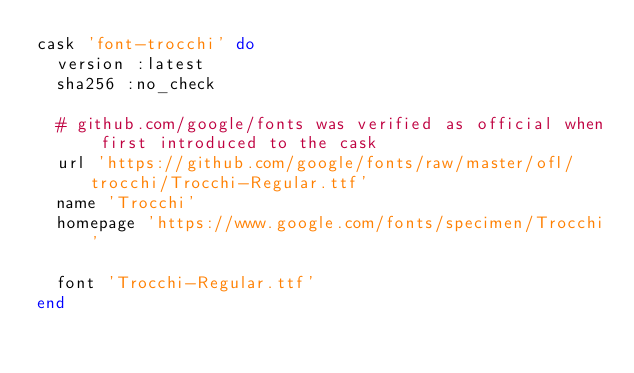<code> <loc_0><loc_0><loc_500><loc_500><_Ruby_>cask 'font-trocchi' do
  version :latest
  sha256 :no_check

  # github.com/google/fonts was verified as official when first introduced to the cask
  url 'https://github.com/google/fonts/raw/master/ofl/trocchi/Trocchi-Regular.ttf'
  name 'Trocchi'
  homepage 'https://www.google.com/fonts/specimen/Trocchi'

  font 'Trocchi-Regular.ttf'
end
</code> 